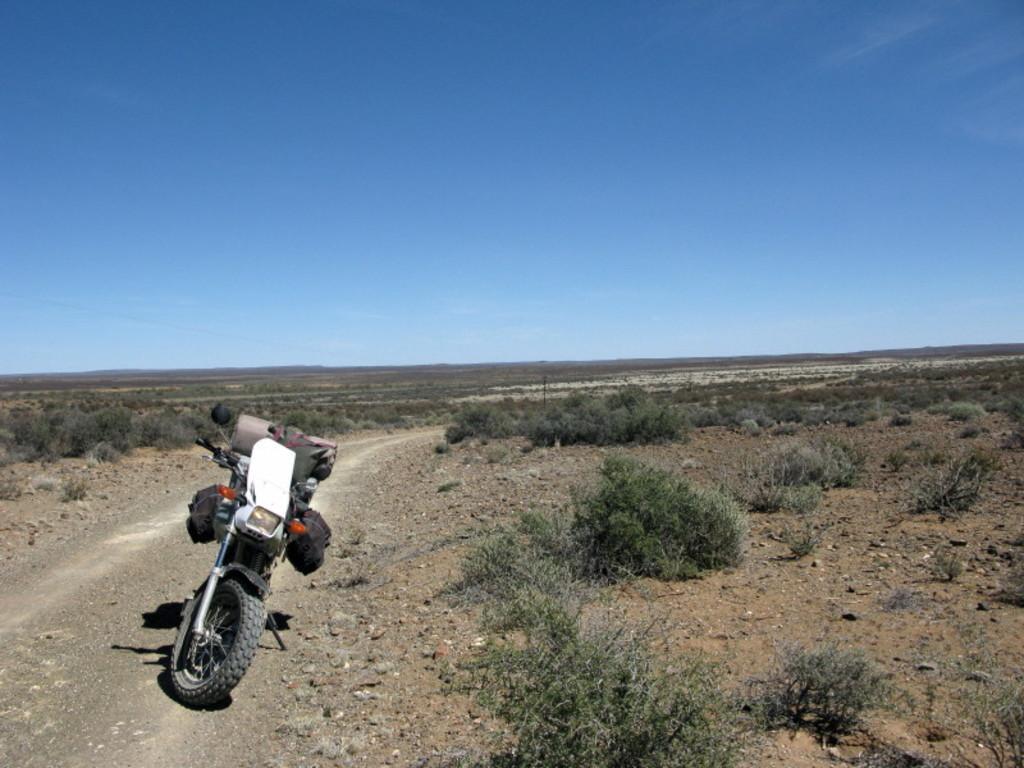Please provide a concise description of this image. This image consists of a bike. On which we can see the bags. At the bottom, there is ground. And we can see small plants on the ground. At the top, there is sky. 